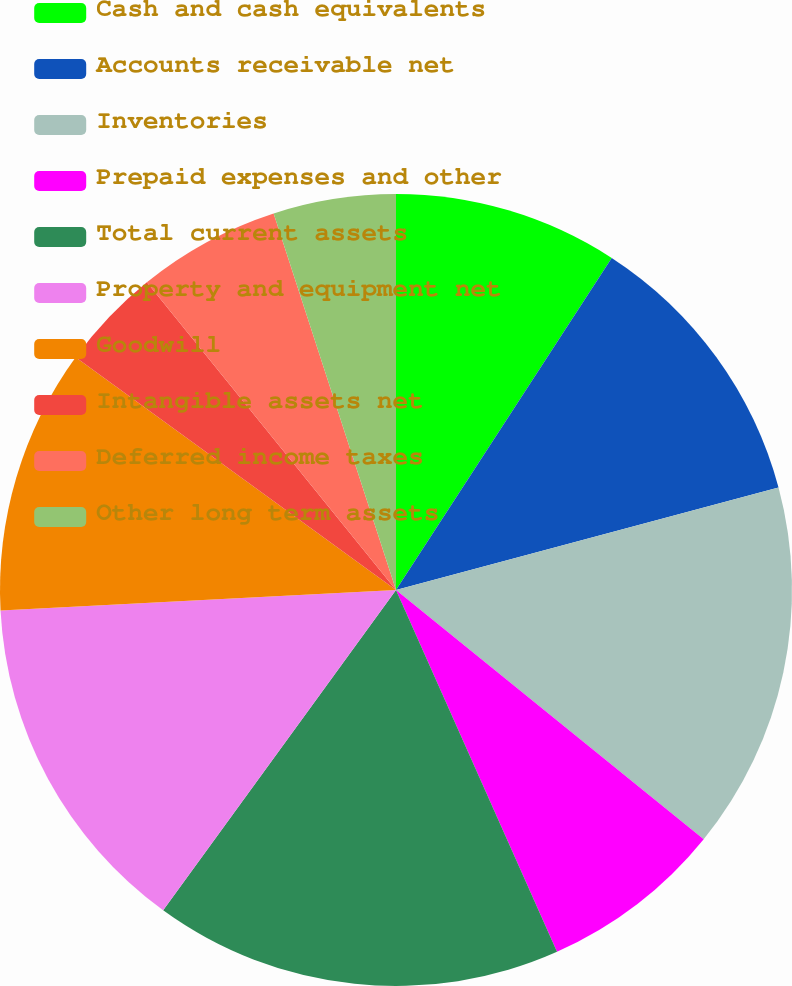Convert chart. <chart><loc_0><loc_0><loc_500><loc_500><pie_chart><fcel>Cash and cash equivalents<fcel>Accounts receivable net<fcel>Inventories<fcel>Prepaid expenses and other<fcel>Total current assets<fcel>Property and equipment net<fcel>Goodwill<fcel>Intangible assets net<fcel>Deferred income taxes<fcel>Other long term assets<nl><fcel>9.17%<fcel>11.67%<fcel>15.0%<fcel>7.5%<fcel>16.67%<fcel>14.17%<fcel>10.83%<fcel>4.17%<fcel>5.83%<fcel>5.0%<nl></chart> 